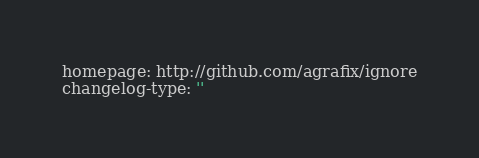Convert code to text. <code><loc_0><loc_0><loc_500><loc_500><_YAML_>homepage: http://github.com/agrafix/ignore
changelog-type: ''</code> 